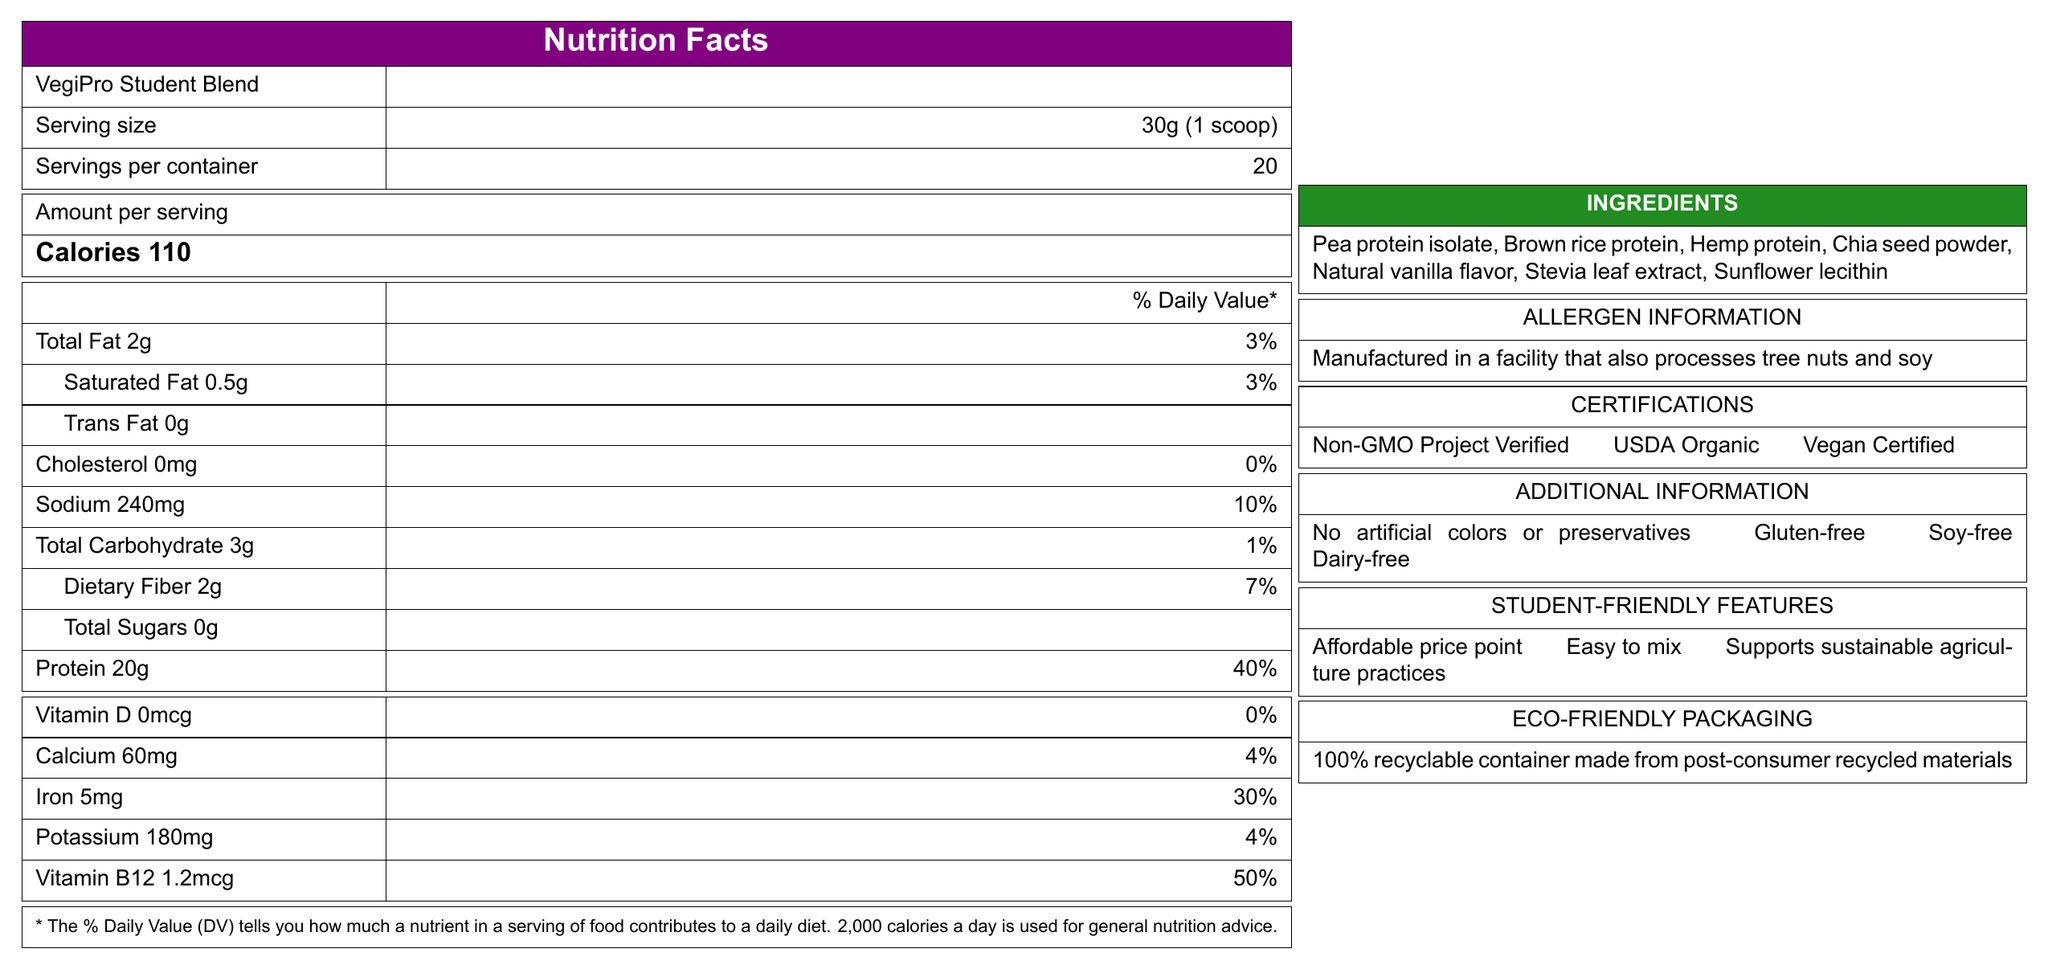what is the serving size of the VegiPro Student Blend? The serving size is explicitly mentioned in the document as "30g (1 scoop)".
Answer: 30g (1 scoop) how many calories are in one serving of VegiPro Student Blend? The amount of calories per serving is indicated as 110 in the document.
Answer: 110 what is the total fat content per serving? The total fat content per serving is listed as "2g" in the document.
Answer: 2g how much sodium does one serving contain? The sodium content per serving is stated as "240mg" in the document.
Answer: 240mg which vitamins and minerals are present in the VegiPro Student Blend, and in what amounts? The amounts of vitamins and minerals are listed in the document: Vitamin D (0mcg), Calcium (60mg), Iron (5mg), Potassium (180mg), and Vitamin B12 (1.2mcg).
Answer: Vitamin D (0mcg), Calcium (60mg), Iron (5mg), Potassium (180mg), Vitamin B12 (1.2mcg) what certifications does the product have? The document lists three certifications: Non-GMO Project Verified, USDA Organic, and Vegan Certified.
Answer: Non-GMO Project Verified, USDA Organic, Vegan Certified what are the allergens associated with the VegiPro Student Blend? The allergen information section indicates that the product is manufactured in a facility that also processes tree nuts and soy.
Answer: Tree nuts and soy describe the additional information related to the VegiPro Student Blend. The additional information section lists that the product has no artificial colors or preservatives, is gluten-free, soy-free, and dairy-free.
Answer: No artificial colors or preservatives, Gluten-free, Soy-free, Dairy-free what are the student-friendly features of the VegiPro Student Blend? The document lists three student-friendly features: an affordable price point, ease of mixing with water or plant-based milk, and support for sustainable agriculture practices.
Answer: Affordable price point, Easy to mix with water or plant-based milk, Supports sustainable agriculture practices is the VegiPro Student Blend gluten-free? The document clearly states in the additional information section that the product is gluten-free.
Answer: Yes what is the eco-friendly feature of the product packaging? A. Biodegradable package B. Compostable container C. 100% recyclable container made from post-consumer recycled materials The eco-friendly packaging section highlights that the container is 100% recyclable and made from post-consumer recycled materials.
Answer: C. 100% recyclable container made from post-consumer recycled materials what type of flavor is included in the ingredients? A. Chocolate B. Natural vanilla C. Berry The ingredient list includes "Natural vanilla flavor".
Answer: B. Natural vanilla which ingredient is not listed in the VegiPro Student Blend? The document does not provide any information about ingredients that are not listed.
Answer: Cannot be determined is there any cholesterol in the VegiPro Student Blend? The document specifies that the cholesterol content is 0mg per serving.
Answer: No summarize the main idea of the document. The document is a comprehensive nutrition facts label for the VegiPro Student Blend, highlighting its nutritional values, certifications, allergen warnings, ingredients, and additional student and eco-friendly features.
Answer: The document provides detailed nutritional information for VegiPro Student Blend, a vegan protein powder designed for health-conscious students. It includes serving size, nutritional content, ingredients, allergen information, certifications, and additional features such as being gluten-free, soy-free, and dairy-free. The product also boasts student-friendly and eco-friendly features. 